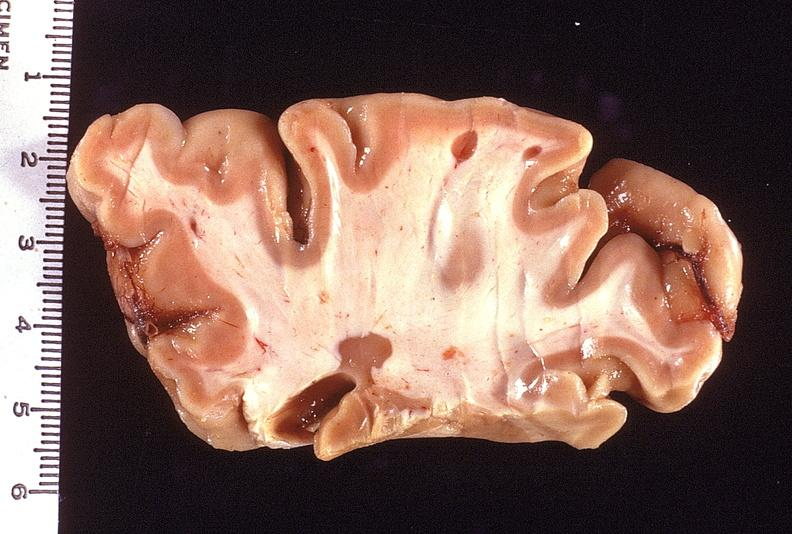what does this image show?
Answer the question using a single word or phrase. Brain 